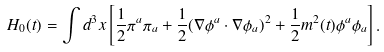Convert formula to latex. <formula><loc_0><loc_0><loc_500><loc_500>H _ { 0 } ( t ) = \int d ^ { 3 } x \left [ \frac { 1 } { 2 } \pi ^ { a } \pi _ { a } + \frac { 1 } { 2 } ( \nabla \phi ^ { a } \cdot \nabla \phi _ { a } ) ^ { 2 } + \frac { 1 } { 2 } m ^ { 2 } ( t ) \phi ^ { a } \phi _ { a } \right ] .</formula> 